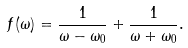Convert formula to latex. <formula><loc_0><loc_0><loc_500><loc_500>f ( \omega ) = \frac { 1 } { \omega - \omega _ { 0 } } + \frac { 1 } { \omega + \omega _ { 0 } } .</formula> 